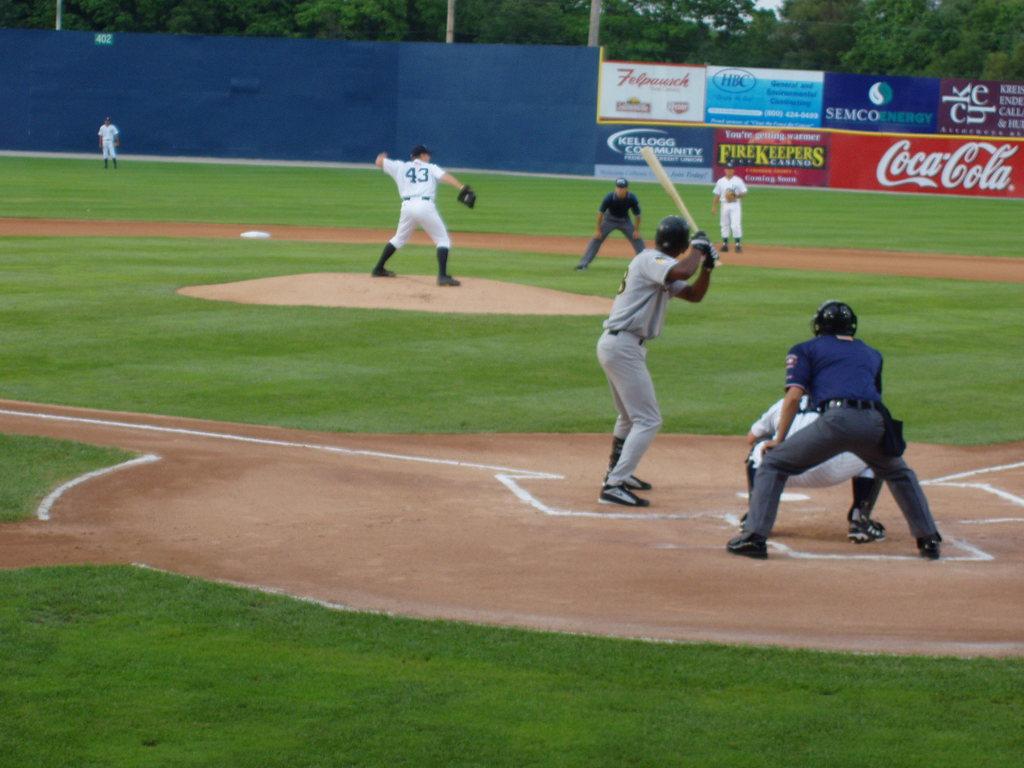What is the jersey number of the pitcher?
Your answer should be very brief. 43. 